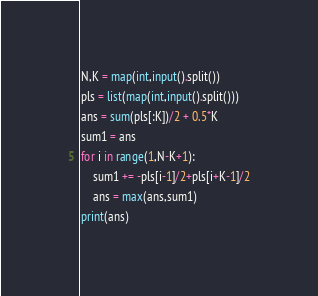Convert code to text. <code><loc_0><loc_0><loc_500><loc_500><_Python_>N,K = map(int,input().split())
pls = list(map(int,input().split()))
ans = sum(pls[:K])/2 + 0.5*K
sum1 = ans
for i in range(1,N-K+1):
    sum1 += -pls[i-1]/2+pls[i+K-1]/2
    ans = max(ans,sum1) 
print(ans)</code> 